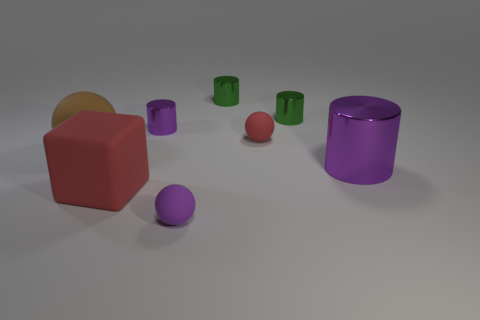What is the material of the ball that is left of the small rubber sphere in front of the large thing that is on the right side of the matte block?
Your answer should be compact. Rubber. Is there a green cylinder that has the same size as the red ball?
Offer a very short reply. Yes. What is the shape of the tiny purple matte object?
Provide a short and direct response. Sphere. How many cylinders are either big matte objects or small metal things?
Your answer should be very brief. 3. Are there the same number of tiny green metal objects that are in front of the tiny purple cylinder and purple things that are in front of the brown object?
Your answer should be compact. No. How many rubber cubes are right of the big purple shiny cylinder that is behind the red rubber object in front of the big purple metal cylinder?
Your answer should be very brief. 0. What shape is the tiny shiny object that is the same color as the big shiny thing?
Offer a very short reply. Cylinder. There is a large block; does it have the same color as the tiny matte thing behind the big purple cylinder?
Your response must be concise. Yes. Is the number of shiny things in front of the tiny purple cylinder greater than the number of small gray objects?
Your response must be concise. Yes. How many objects are either purple metallic cylinders that are behind the brown matte sphere or objects that are in front of the large red matte thing?
Keep it short and to the point. 2. 